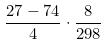Convert formula to latex. <formula><loc_0><loc_0><loc_500><loc_500>\frac { 2 7 - 7 4 } { 4 } \cdot \frac { 8 } { 2 9 8 }</formula> 